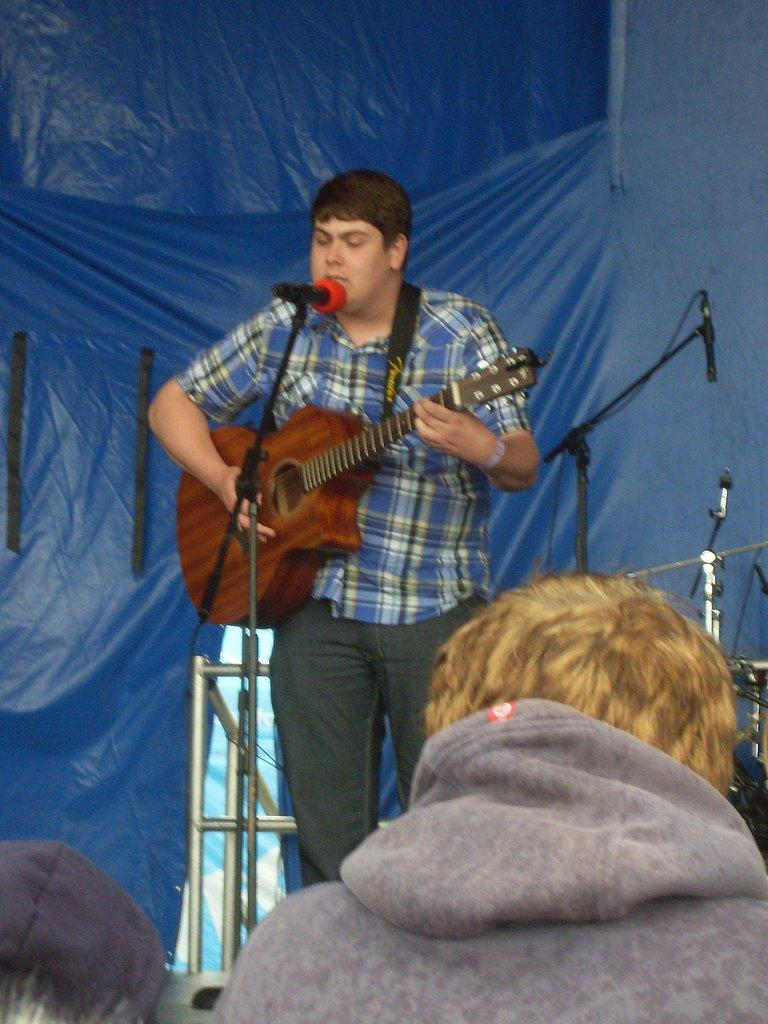What is the man in the image doing? The man is singing on a mic and playing a guitar. What is behind the man? There is a banner behind the man. How many mics are visible in the image? There are present. What type of structures can be seen in the image? There are poles in the image. Is there anyone else in the image besides the man? Yes, there is a person in front of the man. What type of wool is being spun by the cent in the image? There is no wool or cent present in the image. 